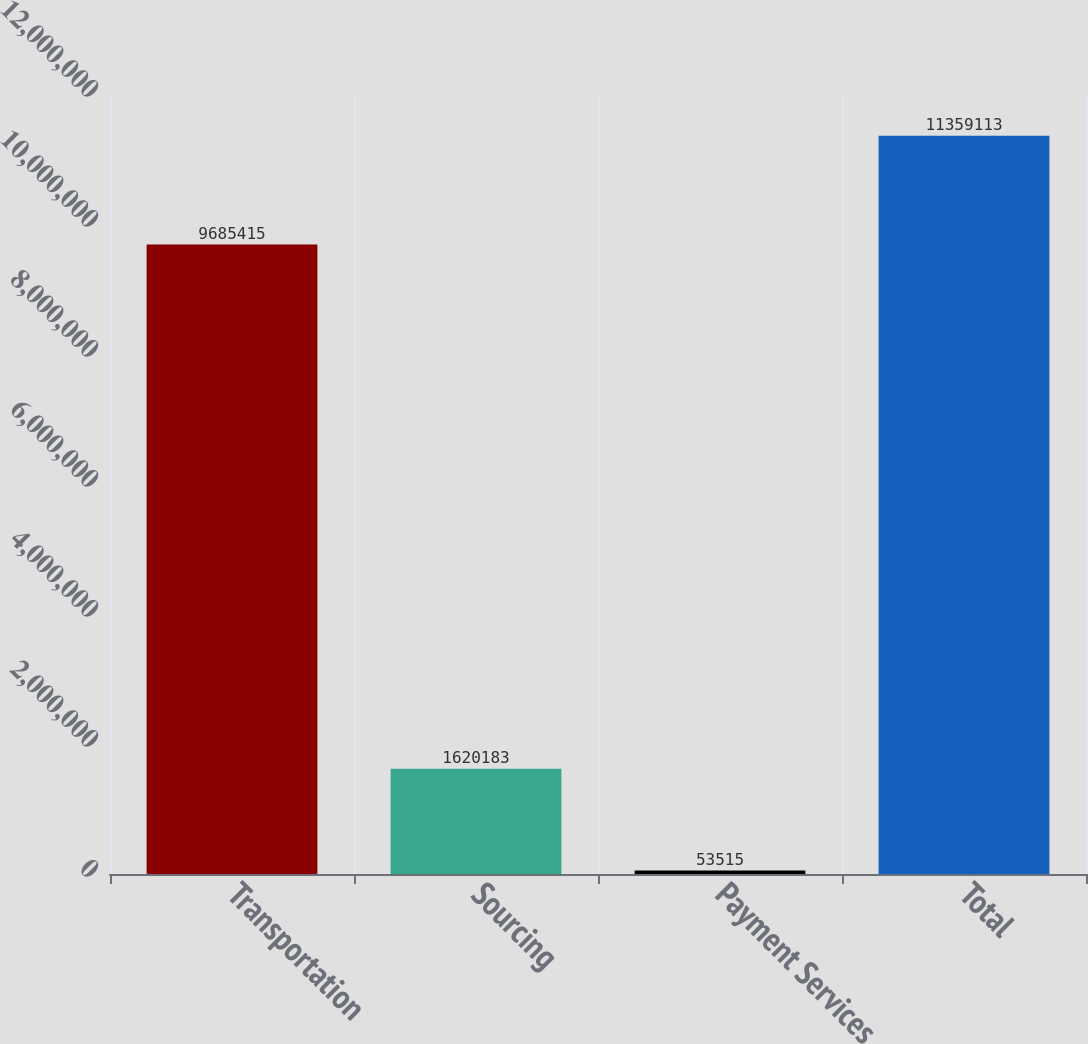Convert chart. <chart><loc_0><loc_0><loc_500><loc_500><bar_chart><fcel>Transportation<fcel>Sourcing<fcel>Payment Services<fcel>Total<nl><fcel>9.68542e+06<fcel>1.62018e+06<fcel>53515<fcel>1.13591e+07<nl></chart> 